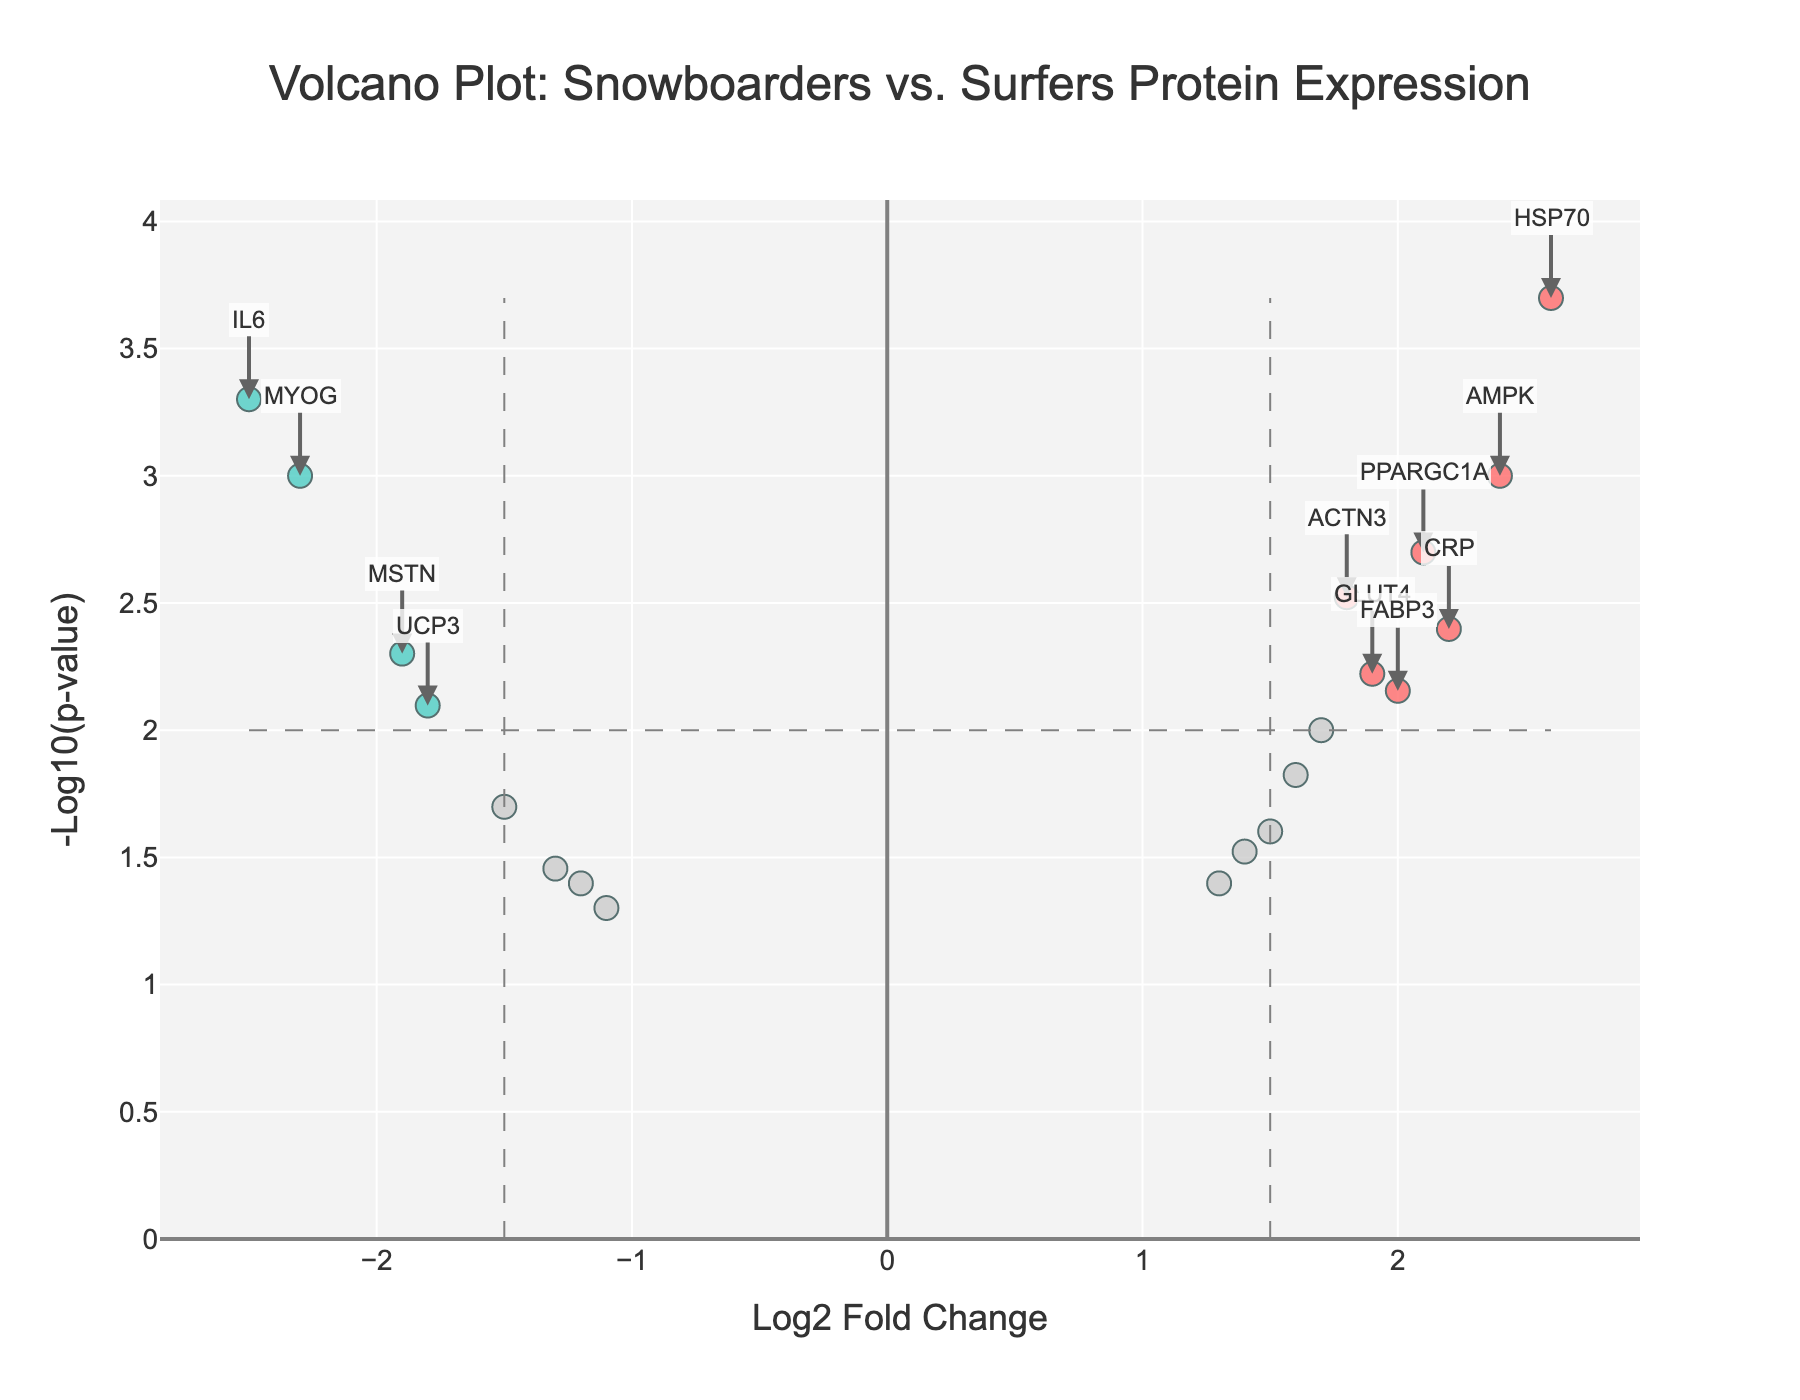What is the title of the plot? The title can be found at the top center of the plot. It summarizes the data represented in the plot.
Answer: Volcano Plot: Snowboarders vs. Surfers Protein Expression What does the x-axis represent? The label on the x-axis shows that it represents the log2 fold change in protein expression levels.
Answer: Log2 Fold Change What color represents significant upregulated proteins? By examining the plot, the color coding indicates that significant upregulated proteins are marked in red.
Answer: Red How many proteins have a log2 fold change greater than 2? By looking at the x-axis and counting the red data points to the right of 2 on the plot, you can identify the number of these points.
Answer: 3 (AMPK, HSP70, CRP) Which protein shows the highest positive log2 fold change? The data point that is furthest to the right on the x-axis indicates the highest positive log2 fold change. This point is labeled on the plot.
Answer: HSP70 What is the p-value threshold indicated by horizontal dashed line? The horizontal dashed line indicates the significance level for p-value, which can be determined by the y-coordinate where this line intersects the y-axis. The threshold is set at a common cutoff of 0.01.
Answer: 0.01 How many proteins have a p-value less than 0.01 and are significantly differentially expressed? These proteins are indicated by either red or blue points as they surpass both the log2 fold change and p-value significance thresholds. Count all such points.
Answer: 9 (MYOG, ACTN3, PPARGC1A, IL6, CRP, AMPK, FABP3, HSP70, MSTN) Which protein has the lowest p-value and what is its log2 fold change? The data point with the highest y-coordinate corresponds to the lowest p-value. Identify this point and its respective x-coordinate to find the log2 fold change.
Answer: HSP70; 2.6 What is the color for non-significant proteins and why? The plot differentiates between significant and non-significant proteins using color. Non-significant proteins are indicated in grey, highlighting them as not meeting the set thresholds for differential expression.
Answer: Grey Compare the log2 fold changes of MYOG and PPARGC1A. Which one is more upregulated in snowboarders compared to surfers? Identify the positions of MYOG and PPARGC1A on the x-axis. MYOG has a negative fold change indicating downregulation, whereas PPARGC1A has a positive fold change indicating upregulation.
Answer: PPARGC1A 